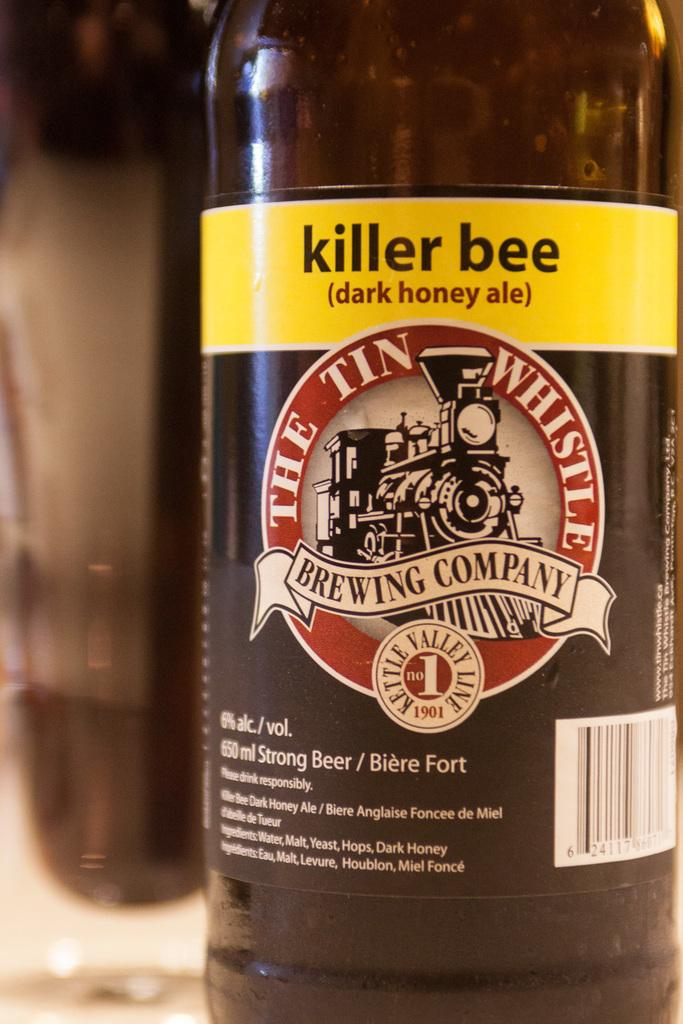<image>
Present a compact description of the photo's key features. A bottle of killer bee dark honey ale from The Tin Whistle Brewing Company. 